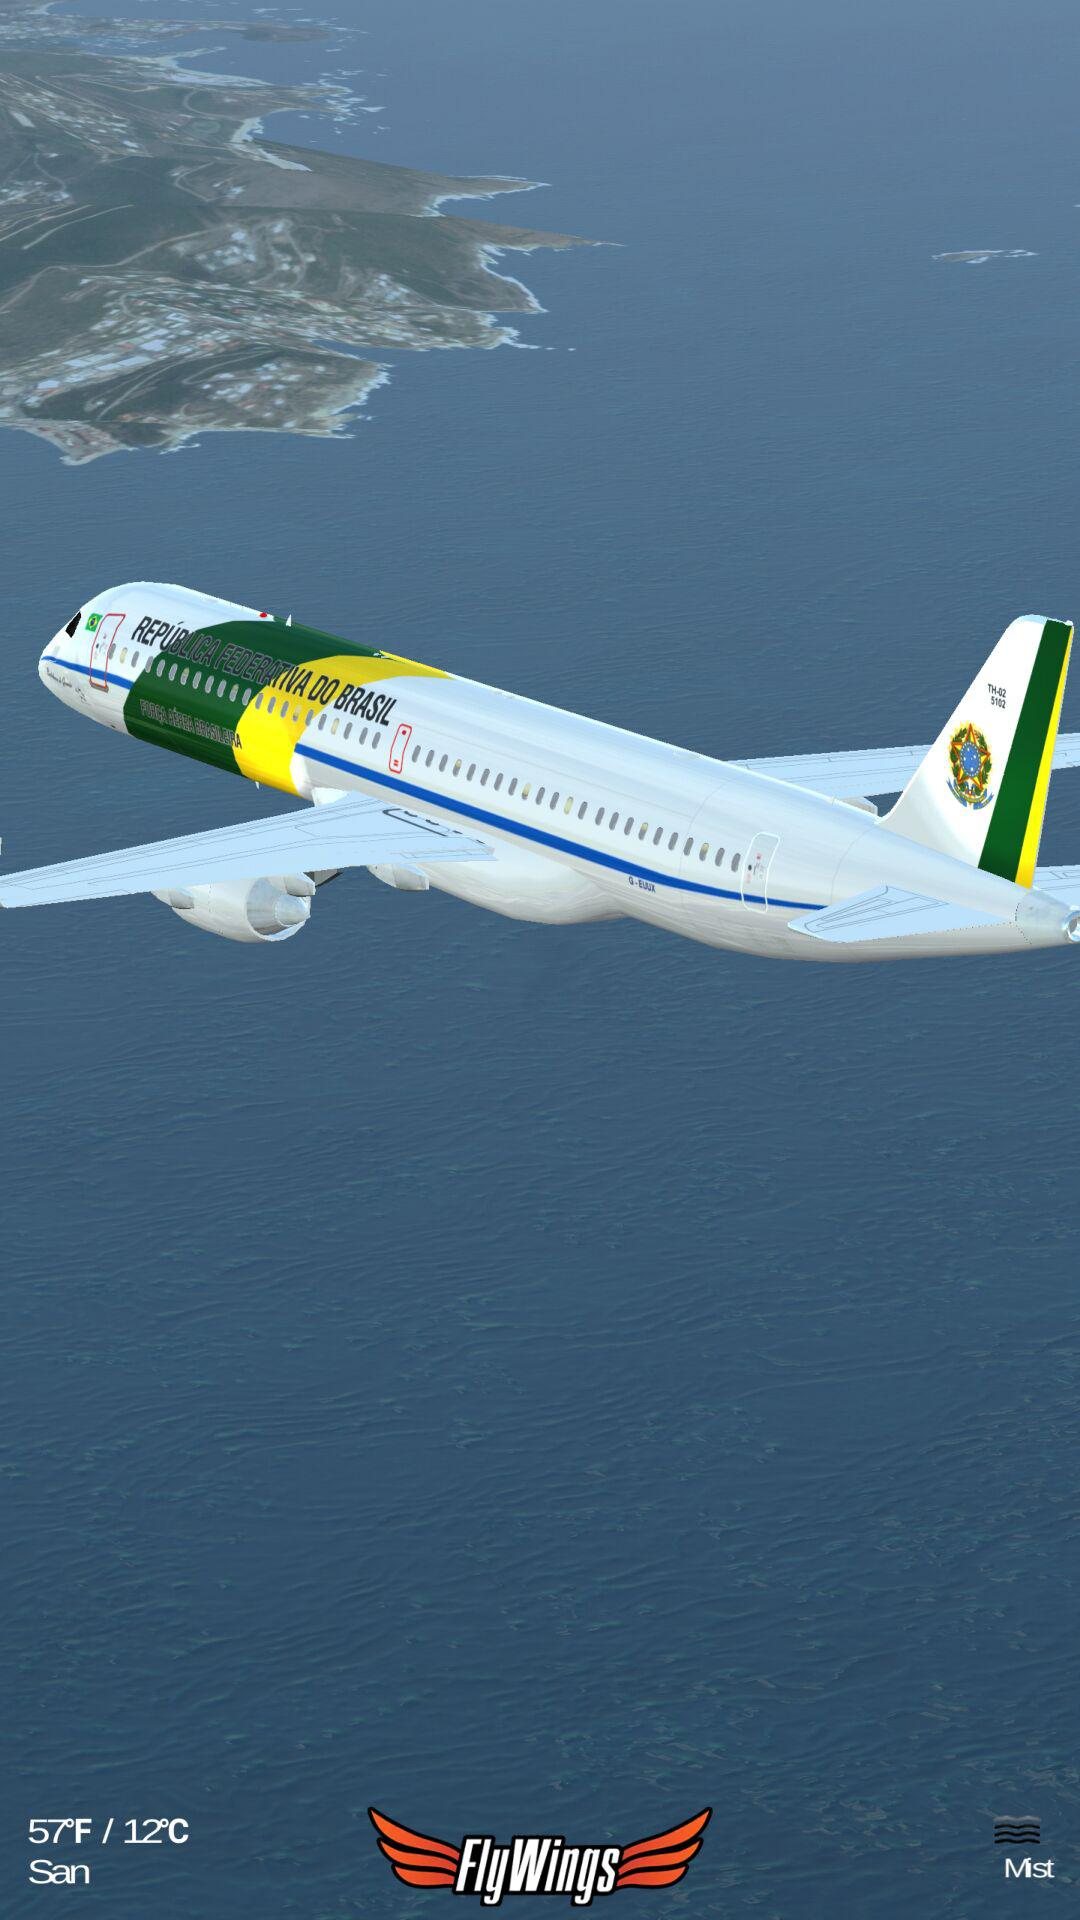How many degrees Fahrenheit is the temperature greater than the temperature in Celsius?
Answer the question using a single word or phrase. 45 